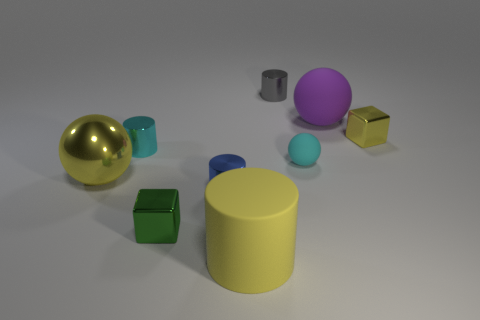Subtract all large yellow spheres. How many spheres are left? 2 Add 1 large cyan shiny spheres. How many objects exist? 10 Subtract all yellow blocks. How many blocks are left? 1 Subtract all spheres. How many objects are left? 6 Subtract 1 cylinders. How many cylinders are left? 3 Subtract all cyan cylinders. How many brown blocks are left? 0 Subtract all matte spheres. Subtract all tiny cyan things. How many objects are left? 5 Add 4 tiny blue objects. How many tiny blue objects are left? 5 Add 3 small blue shiny objects. How many small blue shiny objects exist? 4 Subtract 1 yellow cubes. How many objects are left? 8 